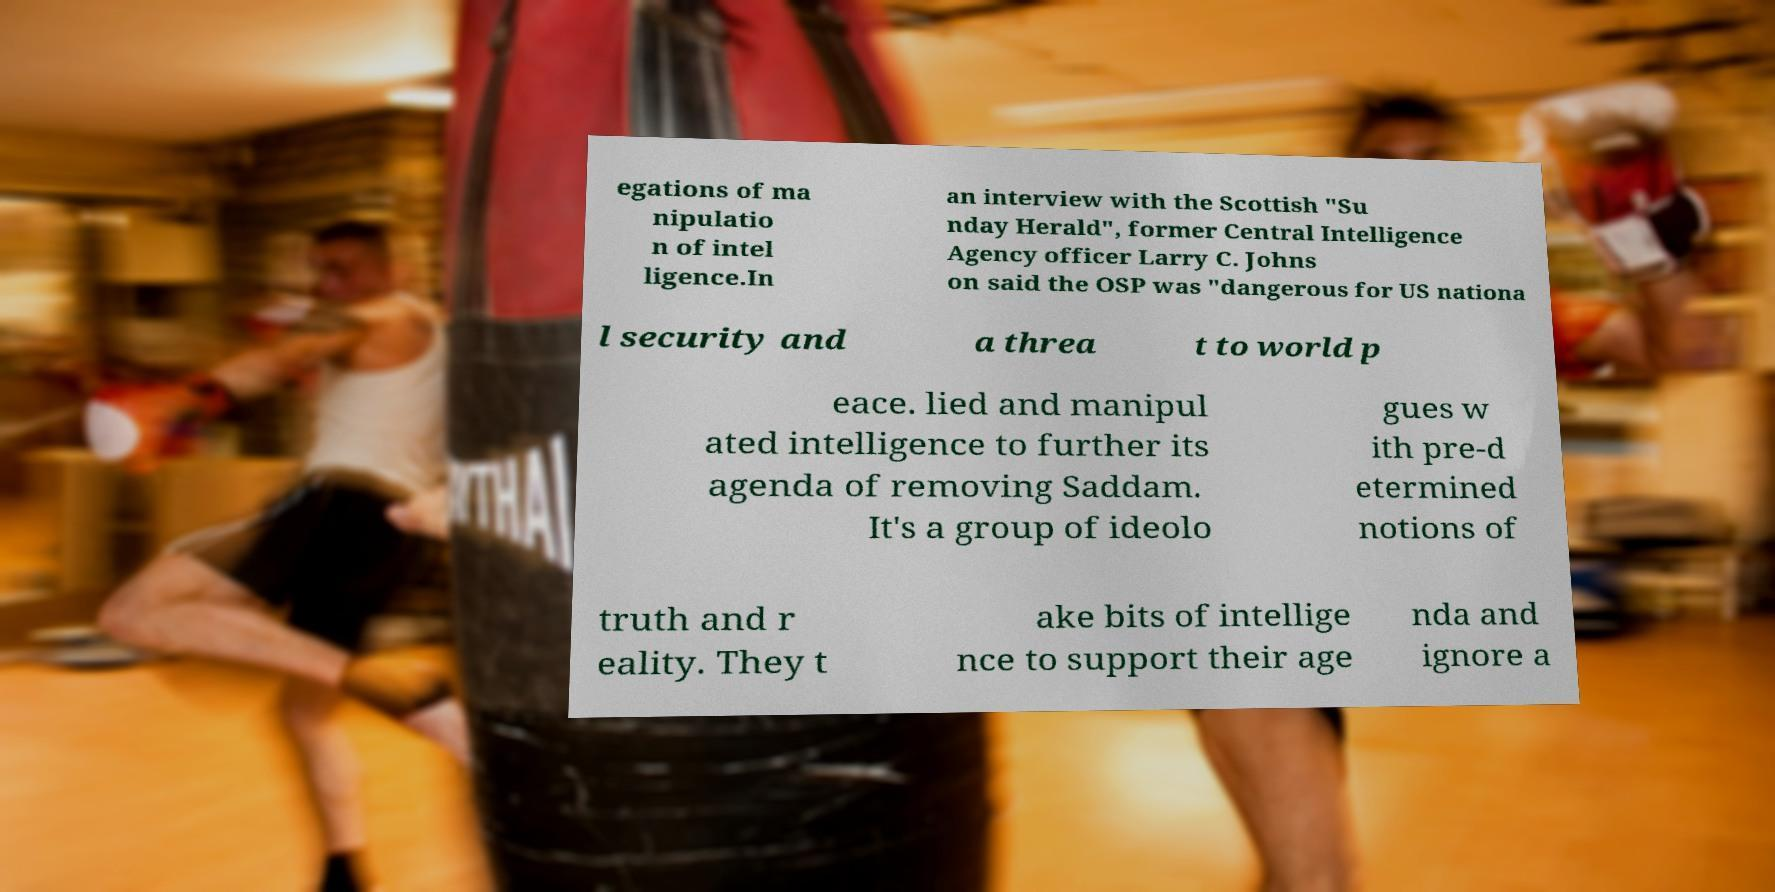Could you assist in decoding the text presented in this image and type it out clearly? egations of ma nipulatio n of intel ligence.In an interview with the Scottish "Su nday Herald", former Central Intelligence Agency officer Larry C. Johns on said the OSP was "dangerous for US nationa l security and a threa t to world p eace. lied and manipul ated intelligence to further its agenda of removing Saddam. It's a group of ideolo gues w ith pre-d etermined notions of truth and r eality. They t ake bits of intellige nce to support their age nda and ignore a 